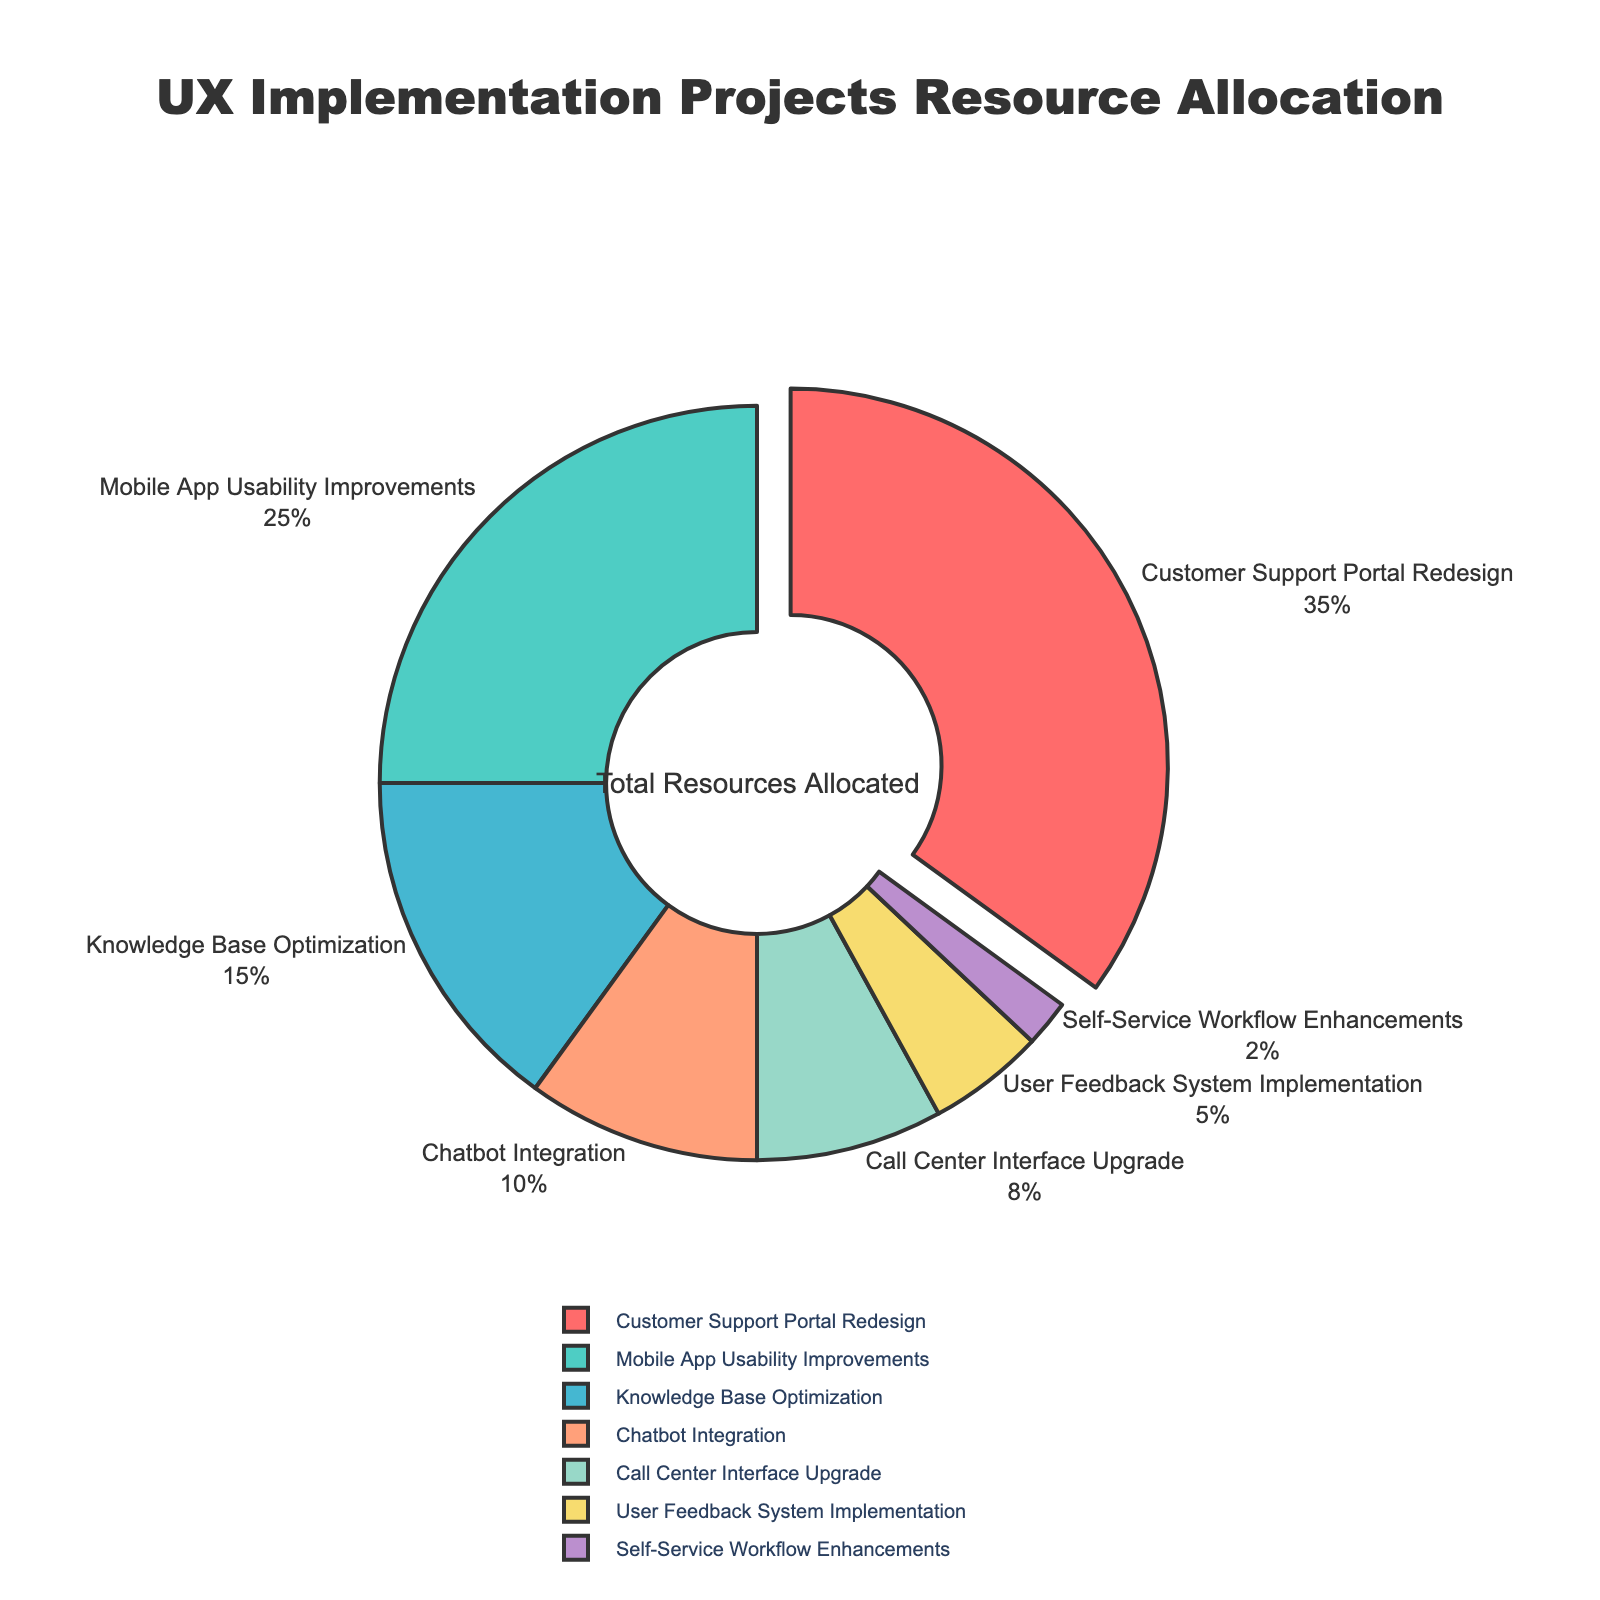What's the largest allocation percentage among the projects? The largest allocation percentage is identified by observing the segment that stands out from the pie chart due to its size and positioning away from the center. Customer Support Portal Redesign has the largest segment pulled out from the pie.
Answer: 35% Which project has the smallest resource allocation? The smallest resource allocation is identified by observing the smallest segment in the pie chart. Self-Service Workflow Enhancements has the smallest segment.
Answer: 2% How much larger is the allocation for Customer Support Portal Redesign compared to Chatbot Integration? Calculate the difference between the two allocation percentages. Customer Support Portal Redesign has 35%, and Chatbot Integration has 10%. The difference is 35% - 10%.
Answer: 25% What is the combined allocation percentage for Knowledge Base Optimization and Call Center Interface Upgrade? To get the combined allocation, sum up the percentages for both projects. Knowledge Base Optimization has 15%, and Call Center Interface Upgrade has 8%. The combined allocation is 15% + 8%.
Answer: 23% Which project has a higher resource allocation: Mobile App Usability Improvements or Call Center Interface Upgrade? Compare the sizes of the segments representing each project. Mobile App Usability Improvements is larger than Call Center Interface Upgrade.
Answer: Mobile App Usability Improvements What is the color of the segment representing Knowledge Base Optimization? Identify the segment labeled as Knowledge Base Optimization by looking at the colors and labels in the pie chart. The segment is colored in a shade of yellow.
Answer: Yellow How many projects have a resource allocation greater than 10%? Count the number of segments that represent allocations larger than 10%. There are four such segments: Customer Support Portal Redesign, Mobile App Usability Improvements, Knowledge Base Optimization, and Chatbot Integration.
Answer: 4 What is the relative size difference between the allocations for Mobile App Usability Improvements and User Feedback System Implementation? Compute the relative size difference by subtracting the percentage of User Feedback System Implementation from Mobile App Usability Improvements. Mobile App Usability Improvements has 25%, and User Feedback System Implementation has 5%. The difference is 25% - 5%.
Answer: 20% Which two projects, if combined, still have a smaller allocation than Customer Support Portal Redesign? Sum the allocations for two projects and compare them with Customer Support Portal Redesign (35%). For example, Knowledge Base Optimization (15%) + Call Center Interface Upgrade (8%) = 23%, which is less than 35%. Another pair is Chatbot Integration (10%) + User Feedback System Implementation (5%) = 15%.
Answer: Knowledge Base Optimization and Call Center Interface Upgrade 